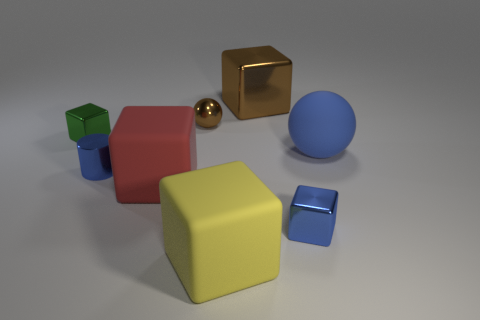There is a thing to the right of the blue metallic block; what is it made of?
Provide a short and direct response. Rubber. There is a blue shiny thing in front of the tiny blue shiny thing on the left side of the small brown shiny ball; what is its size?
Provide a succinct answer. Small. What number of metal cylinders are the same size as the green metallic block?
Your answer should be compact. 1. Does the big block that is behind the big blue sphere have the same color as the tiny shiny thing behind the green metallic object?
Your answer should be very brief. Yes. Are there any big cubes in front of the large brown block?
Provide a short and direct response. Yes. There is a large cube that is both in front of the small green object and on the right side of the tiny brown metal sphere; what color is it?
Provide a short and direct response. Yellow. Is there a tiny block of the same color as the rubber sphere?
Offer a very short reply. Yes. Do the brown thing that is behind the tiny metal ball and the large yellow thing that is right of the metal cylinder have the same material?
Keep it short and to the point. No. There is a matte block behind the big yellow cube; how big is it?
Your answer should be very brief. Large. How big is the red rubber thing?
Your response must be concise. Large. 